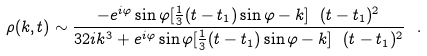Convert formula to latex. <formula><loc_0><loc_0><loc_500><loc_500>\rho ( k , t ) \sim \frac { - e ^ { i \varphi } \sin \varphi [ \frac { 1 } { 3 } ( t - t _ { 1 } ) \sin \varphi - k ] \ ( t - t _ { 1 } ) ^ { 2 } } { 3 2 i k ^ { 3 } + e ^ { i \varphi } \sin \varphi [ \frac { 1 } { 3 } ( t - t _ { 1 } ) \sin \varphi - k ] \ ( t - t _ { 1 } ) ^ { 2 } } \ .</formula> 